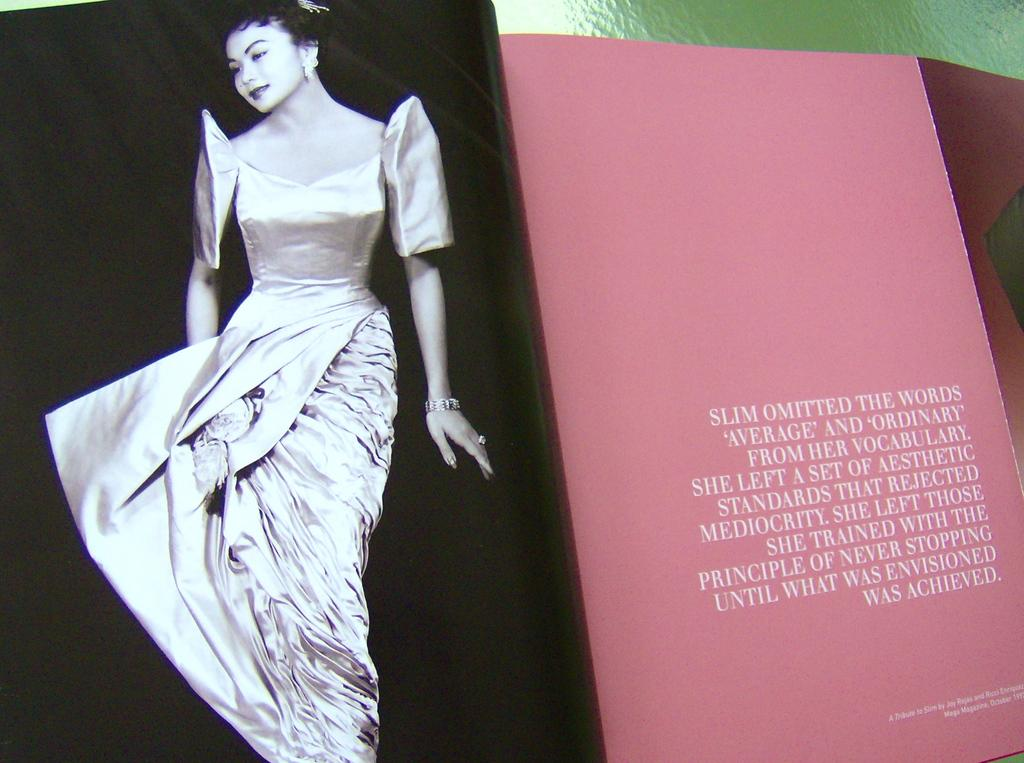<image>
Share a concise interpretation of the image provided. the word slim is on the pink sign 